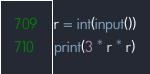<code> <loc_0><loc_0><loc_500><loc_500><_Python_>r = int(input())
print(3 * r * r)
</code> 